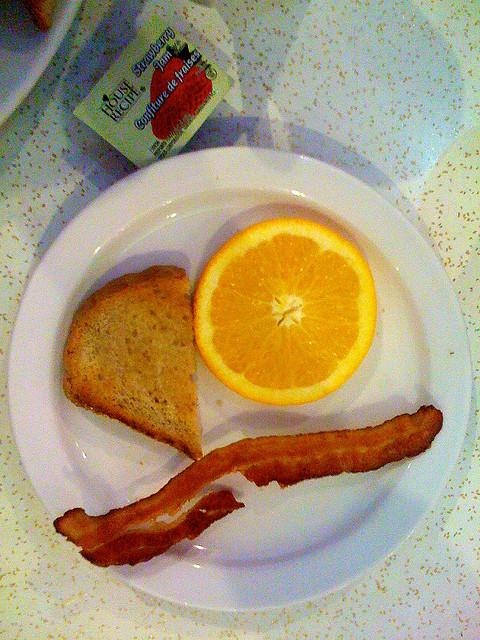What two fruits are shown?
Write a very short answer. Strawberry and orange. Which food on the plate is probably the sweetest?
Give a very brief answer. Orange. Is the meal safe for a toddler to eat?
Short answer required. Yes. What type of surface is the plate sitting on?
Answer briefly. Table. What kind of food can be seen?
Write a very short answer. Breakfast. Is this breakfast been served?
Quick response, please. Yes. Shouldn't the bread be toasted?
Short answer required. Yes. Is this breakfast?
Short answer required. Yes. What color is the background?
Concise answer only. White. What kind of food is shown?
Keep it brief. Breakfast. How many red apples are there?
Write a very short answer. 0. What is the countertop made of?
Answer briefly. Formica. What flavor is the jelly?
Give a very brief answer. Strawberry. What color is the table?
Answer briefly. White. Is there any silverware on the plate?
Keep it brief. No. Is this breakfast warm?
Be succinct. Yes. How many oranges are there?
Quick response, please. 1. How many slices of bread are here?
Short answer required. 1. What is on top of the white plates?
Give a very brief answer. Breakfast. What is on the plate?
Be succinct. Food. What are the meats on this breakfast plate?
Quick response, please. Bacon. What are the orange things?
Keep it brief. Orange. What kind of food is this?
Be succinct. Breakfast. How many pears are on the plate?
Write a very short answer. 0. Something round and something sharp?
Short answer required. No. What is the table made of?
Keep it brief. Formica. What type of fruit is this?
Answer briefly. Orange. Is there fur on the image?
Be succinct. No. What is the flavor of the marmalade?
Answer briefly. Strawberry. How many oranges in the plate?
Be succinct. 1. What three non meat items are being served with this meal?
Answer briefly. Orange, toast, jelly. What type of orange is this?
Give a very brief answer. Navel. What fruit is on the plate?
Be succinct. Orange. What is the plate made of?
Be succinct. Plastic. What is in the plate?
Answer briefly. Breakfast. What color are the dishes?
Give a very brief answer. White. Is this a well-balanced breakfast?
Give a very brief answer. Yes. Is this a dessert?
Keep it brief. No. What is the name of this fruit?
Answer briefly. Orange. Is this food attractively presented?
Concise answer only. Yes. What color is the plate?
Quick response, please. White. 